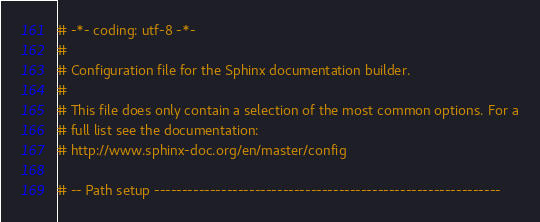Convert code to text. <code><loc_0><loc_0><loc_500><loc_500><_Python_># -*- coding: utf-8 -*-
#
# Configuration file for the Sphinx documentation builder.
#
# This file does only contain a selection of the most common options. For a
# full list see the documentation:
# http://www.sphinx-doc.org/en/master/config

# -- Path setup --------------------------------------------------------------
</code> 